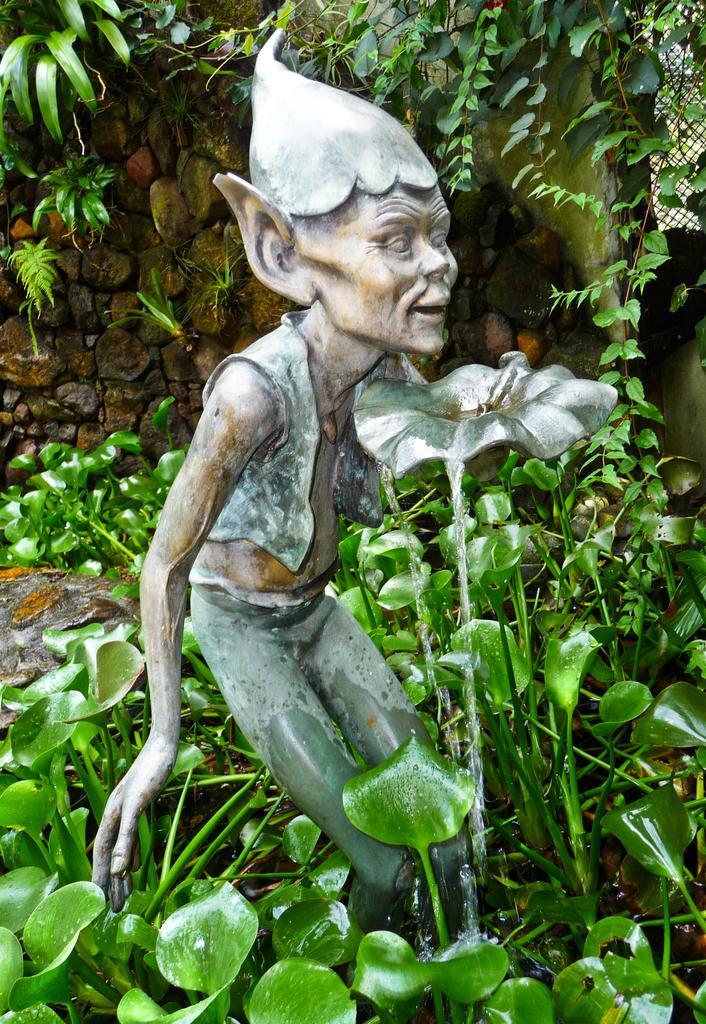How would you summarize this image in a sentence or two? In this image we can see a sculpture and water is falling from it. Bottom of the image and top of the image plants are present. 